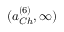Convert formula to latex. <formula><loc_0><loc_0><loc_500><loc_500>( a _ { C h } ^ { ( 6 ) } , \infty )</formula> 